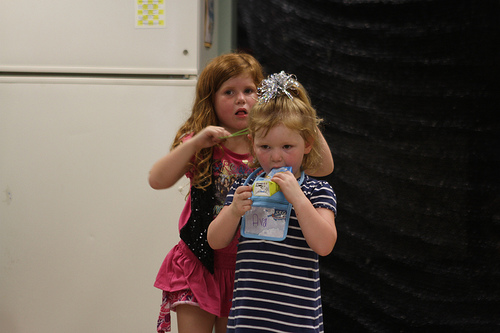<image>
Can you confirm if the girl is next to the girl? Yes. The girl is positioned adjacent to the girl, located nearby in the same general area. 